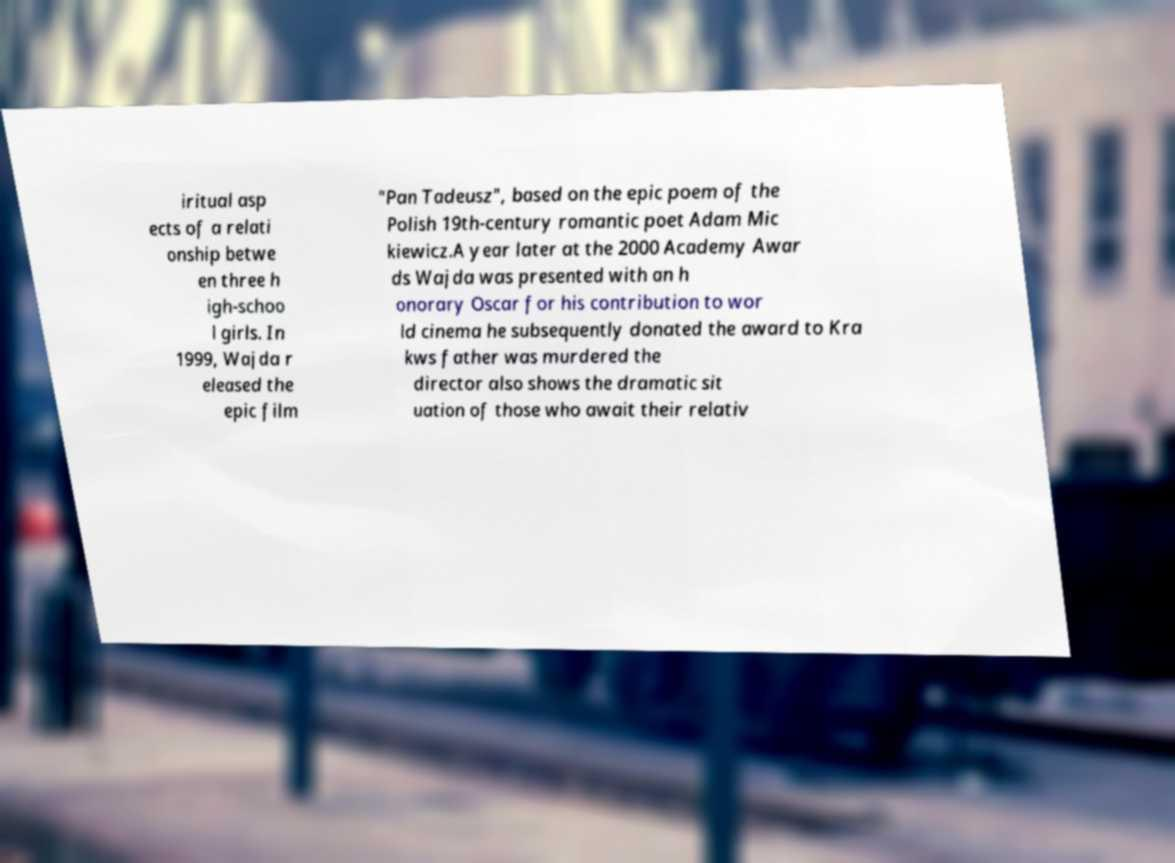There's text embedded in this image that I need extracted. Can you transcribe it verbatim? iritual asp ects of a relati onship betwe en three h igh-schoo l girls. In 1999, Wajda r eleased the epic film "Pan Tadeusz", based on the epic poem of the Polish 19th-century romantic poet Adam Mic kiewicz.A year later at the 2000 Academy Awar ds Wajda was presented with an h onorary Oscar for his contribution to wor ld cinema he subsequently donated the award to Kra kws father was murdered the director also shows the dramatic sit uation of those who await their relativ 